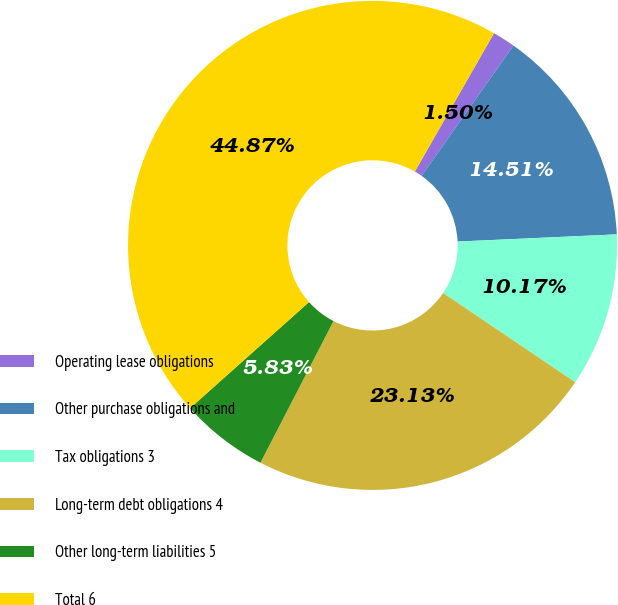Convert chart. <chart><loc_0><loc_0><loc_500><loc_500><pie_chart><fcel>Operating lease obligations<fcel>Other purchase obligations and<fcel>Tax obligations 3<fcel>Long-term debt obligations 4<fcel>Other long-term liabilities 5<fcel>Total 6<nl><fcel>1.5%<fcel>14.51%<fcel>10.17%<fcel>23.13%<fcel>5.83%<fcel>44.87%<nl></chart> 